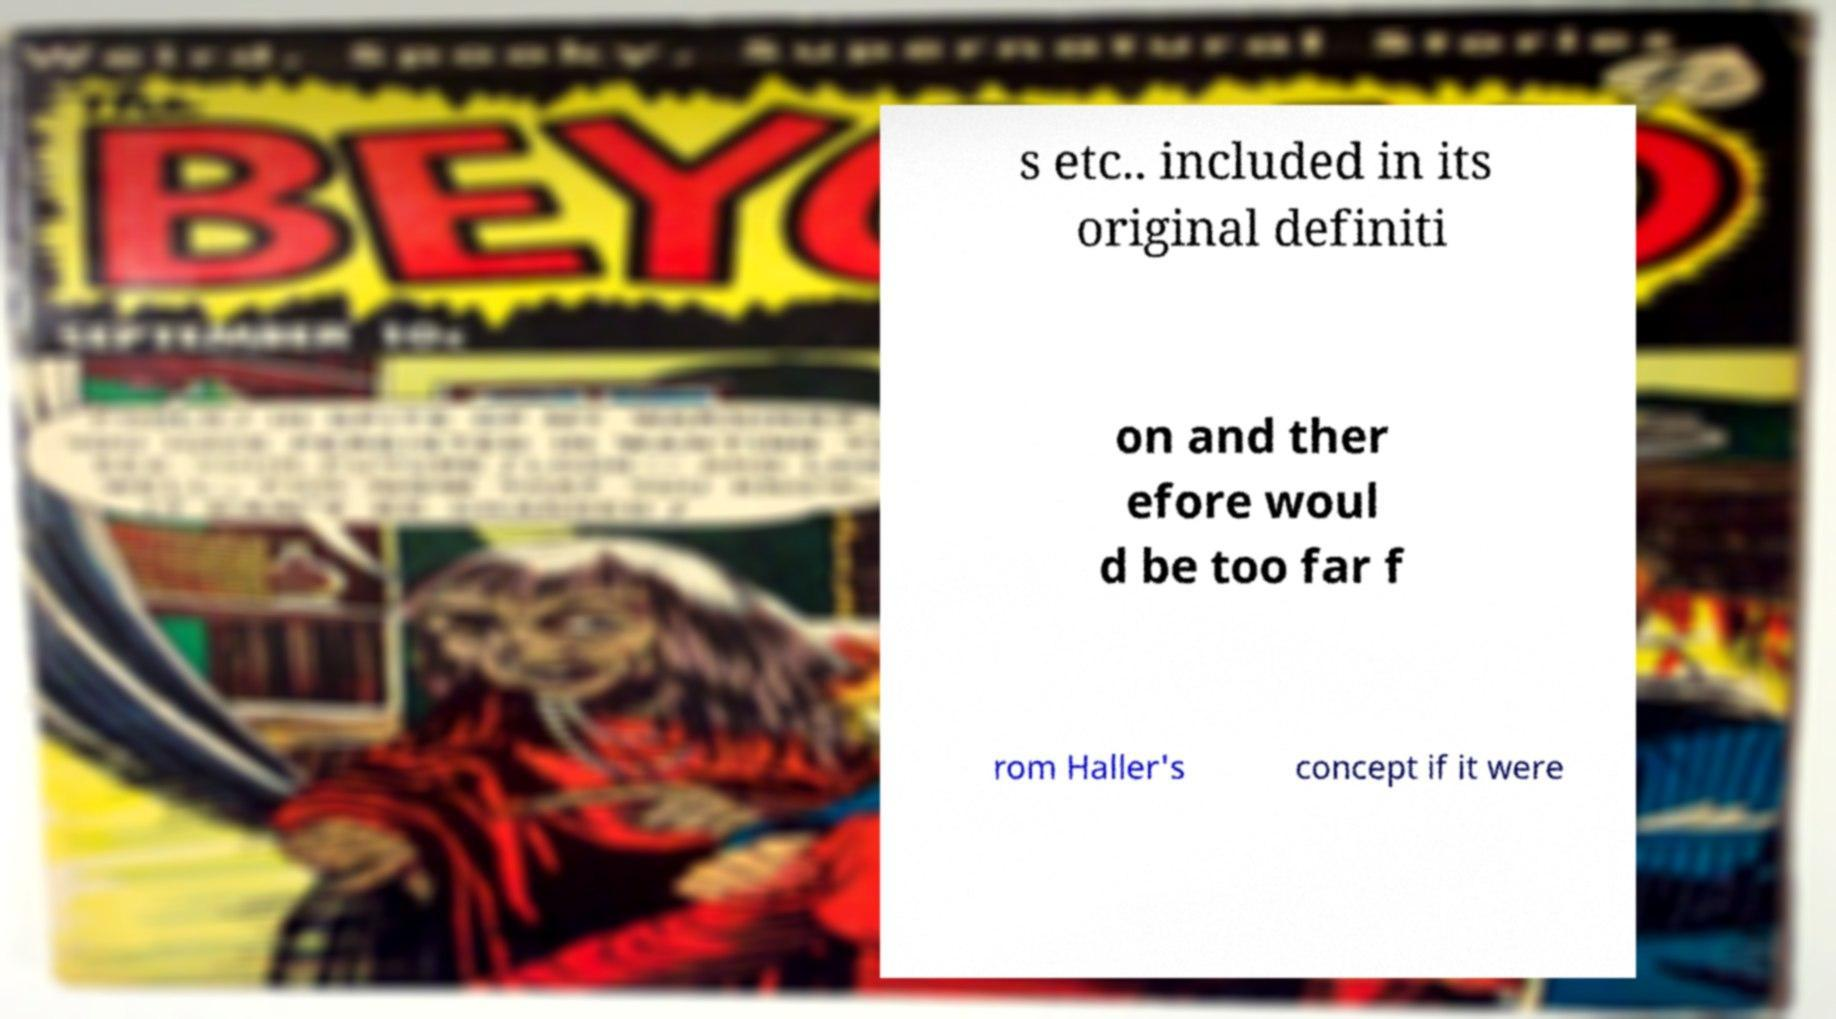What messages or text are displayed in this image? I need them in a readable, typed format. s etc.. included in its original definiti on and ther efore woul d be too far f rom Haller's concept if it were 